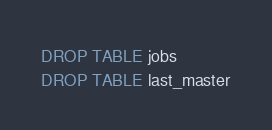Convert code to text. <code><loc_0><loc_0><loc_500><loc_500><_SQL_>DROP TABLE jobs
DROP TABLE last_master
</code> 